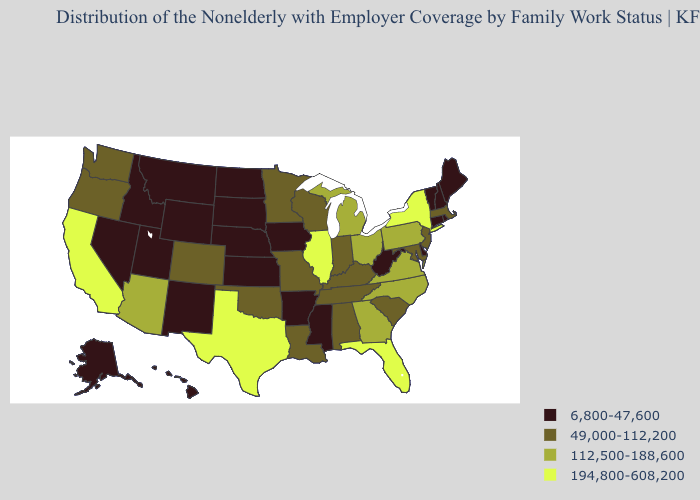What is the value of Wisconsin?
Short answer required. 49,000-112,200. What is the value of Mississippi?
Answer briefly. 6,800-47,600. Does Wisconsin have a lower value than Illinois?
Quick response, please. Yes. Does New Mexico have the lowest value in the USA?
Short answer required. Yes. Does the first symbol in the legend represent the smallest category?
Answer briefly. Yes. What is the lowest value in the USA?
Be succinct. 6,800-47,600. What is the value of Maryland?
Keep it brief. 49,000-112,200. Name the states that have a value in the range 194,800-608,200?
Keep it brief. California, Florida, Illinois, New York, Texas. What is the highest value in the USA?
Quick response, please. 194,800-608,200. Does Tennessee have a higher value than Rhode Island?
Write a very short answer. Yes. What is the value of South Carolina?
Concise answer only. 49,000-112,200. Among the states that border Vermont , does New Hampshire have the lowest value?
Answer briefly. Yes. What is the lowest value in states that border Washington?
Be succinct. 6,800-47,600. Does Minnesota have a higher value than Rhode Island?
Concise answer only. Yes. What is the value of Maine?
Keep it brief. 6,800-47,600. 